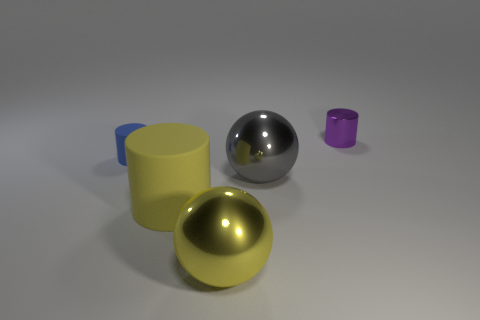Add 2 yellow matte things. How many objects exist? 7 Subtract all spheres. How many objects are left? 3 Add 3 yellow shiny spheres. How many yellow shiny spheres exist? 4 Subtract 0 purple spheres. How many objects are left? 5 Subtract all big cyan shiny balls. Subtract all large gray things. How many objects are left? 4 Add 5 blue rubber things. How many blue rubber things are left? 6 